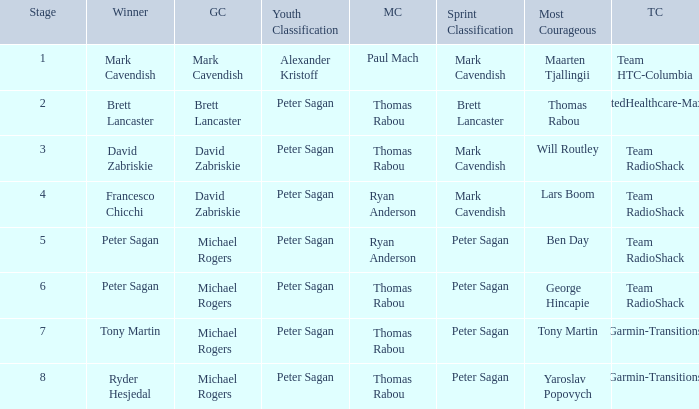When Peter Sagan won the youth classification and Thomas Rabou won the most corageous, who won the sprint classification? Brett Lancaster. 